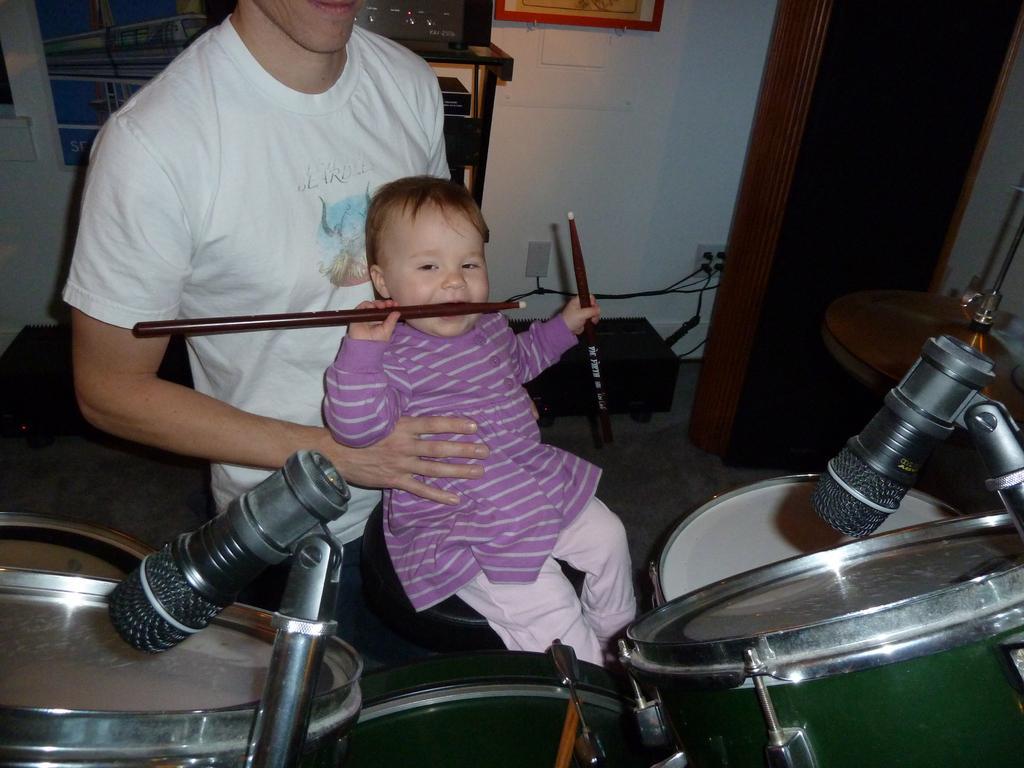Describe this image in one or two sentences. In a picture one man is standing in a white shirt and holding a baby where the baby is wearing a purple dress and sitting on the stool in front of the drums and sticks in baby hands and behind the man there is a wall and some speakers and wires and photos on the wall. 